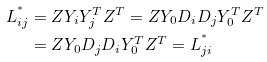<formula> <loc_0><loc_0><loc_500><loc_500>L _ { i j } ^ { ^ { * } } & = Z Y _ { i } Y _ { j } ^ { T } Z ^ { T } = Z Y _ { 0 } D _ { i } D _ { j } Y _ { 0 } ^ { T } Z ^ { T } \\ & = Z Y _ { 0 } D _ { j } D _ { i } Y _ { 0 } ^ { T } Z ^ { T } = L _ { j i } ^ { ^ { * } }</formula> 